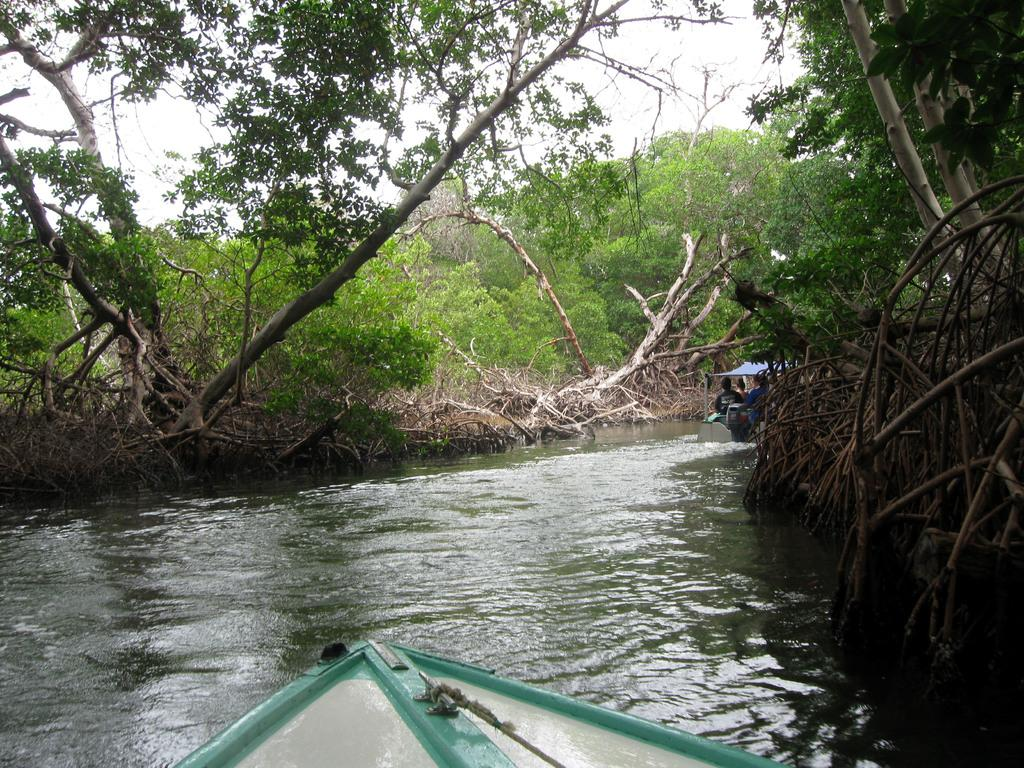What body of water is at the bottom of the image? There is a canal at the bottom of the image. What is on the canal? Boats are present on the canal. Who is in the boats? There are people sitting in the boats. What can be seen in the background of the image? There are trees and the sky visible in the background of the image. What type of advice is being given by the pie in the image? There is no pie present in the image, so it cannot provide any advice. 